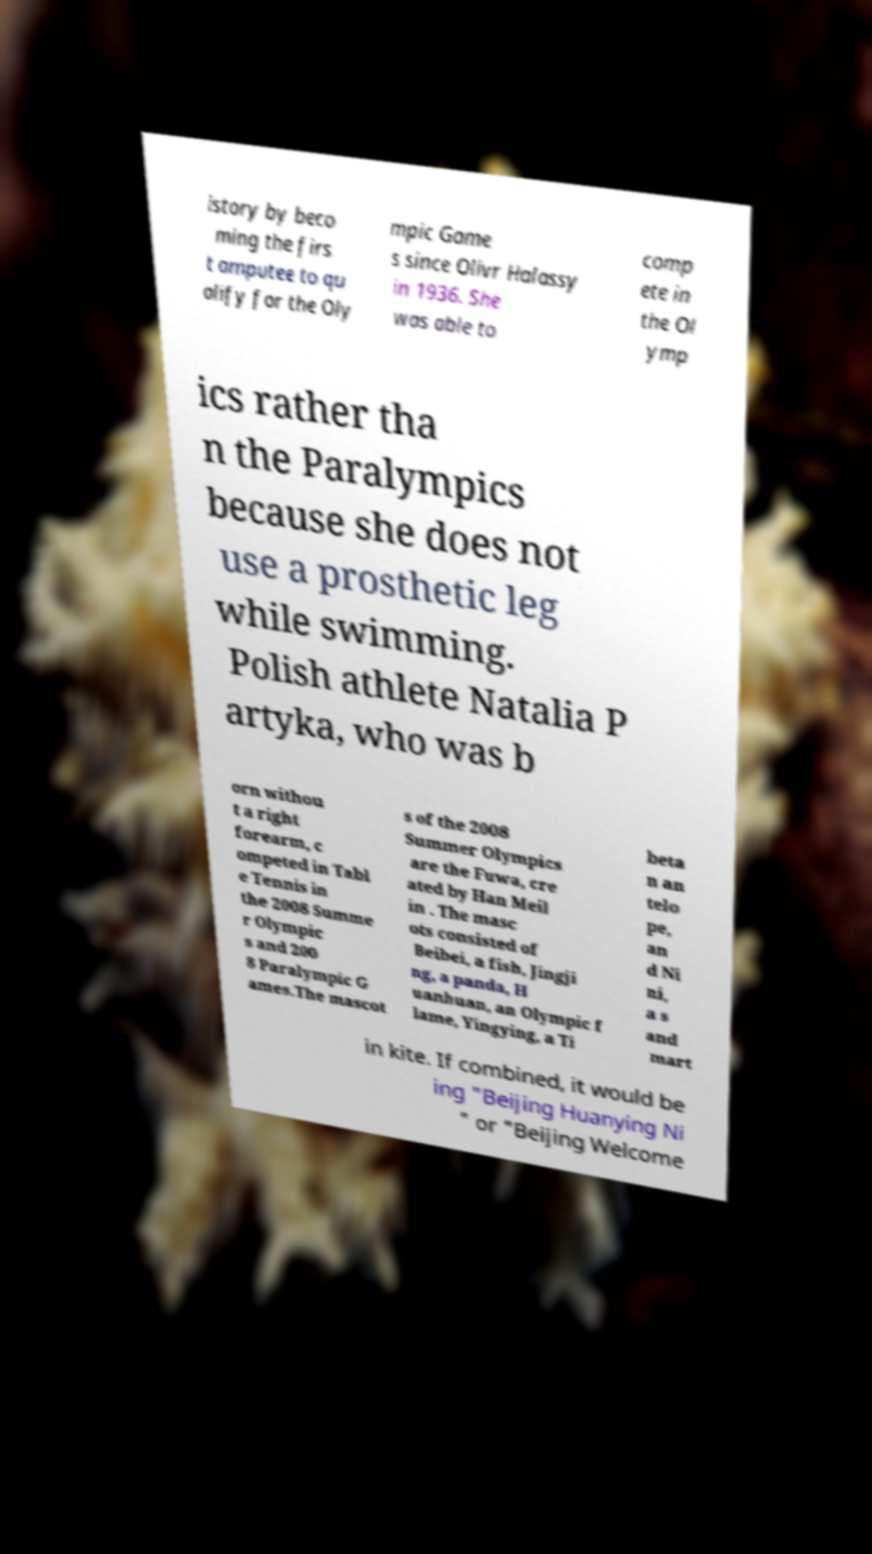There's text embedded in this image that I need extracted. Can you transcribe it verbatim? istory by beco ming the firs t amputee to qu alify for the Oly mpic Game s since Olivr Halassy in 1936. She was able to comp ete in the Ol ymp ics rather tha n the Paralympics because she does not use a prosthetic leg while swimming. Polish athlete Natalia P artyka, who was b orn withou t a right forearm, c ompeted in Tabl e Tennis in the 2008 Summe r Olympic s and 200 8 Paralympic G ames.The mascot s of the 2008 Summer Olympics are the Fuwa, cre ated by Han Meil in . The masc ots consisted of Beibei, a fish, Jingji ng, a panda, H uanhuan, an Olympic f lame, Yingying, a Ti beta n an telo pe, an d Ni ni, a s and mart in kite. If combined, it would be ing "Beijing Huanying Ni " or "Beijing Welcome 